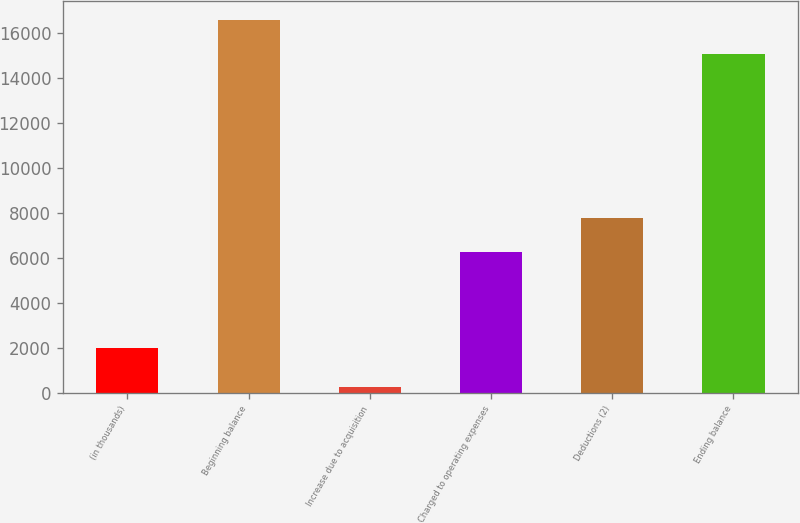<chart> <loc_0><loc_0><loc_500><loc_500><bar_chart><fcel>(in thousands)<fcel>Beginning balance<fcel>Increase due to acquisition<fcel>Charged to operating expenses<fcel>Deductions (2)<fcel>Ending balance<nl><fcel>2011<fcel>16576.4<fcel>269<fcel>6271<fcel>7767.4<fcel>15080<nl></chart> 